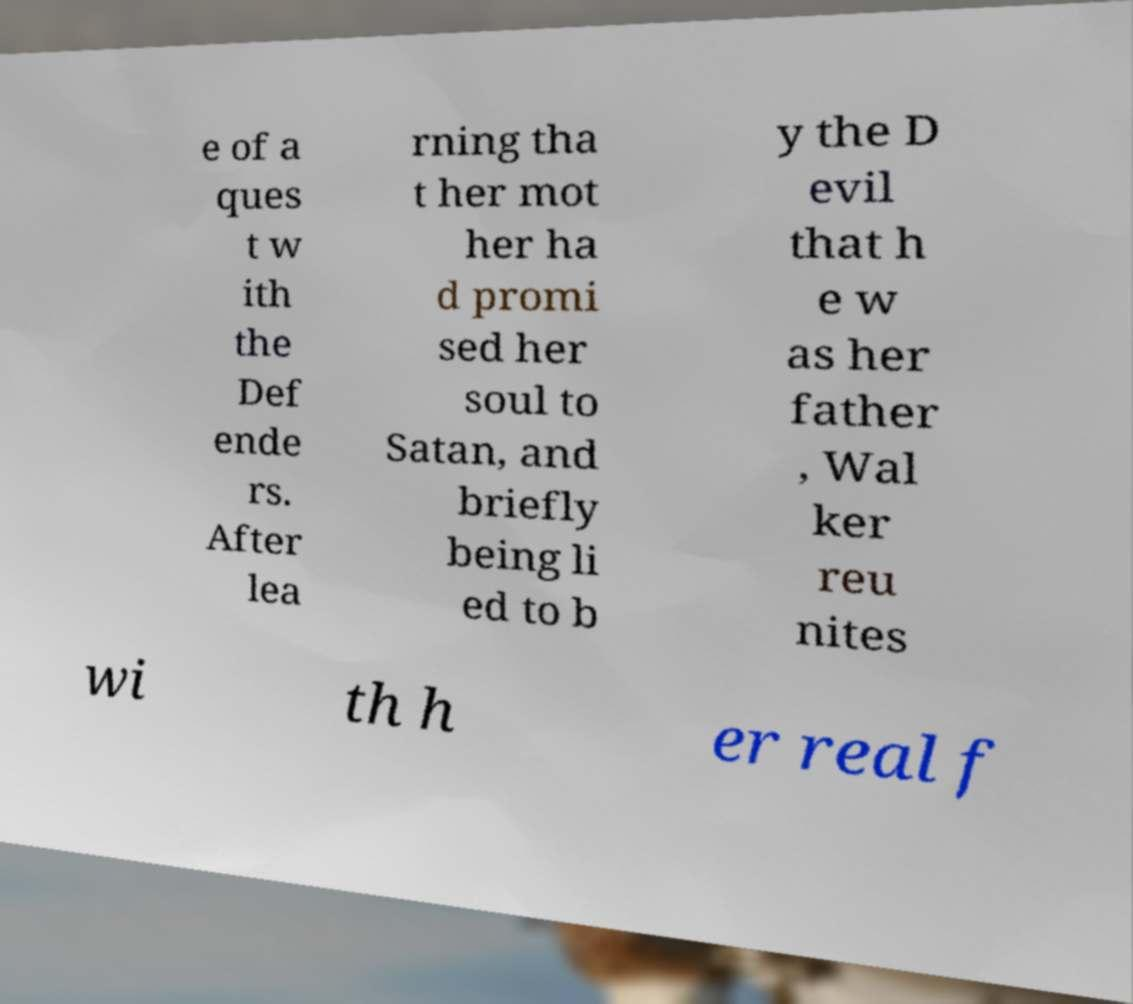Could you assist in decoding the text presented in this image and type it out clearly? e of a ques t w ith the Def ende rs. After lea rning tha t her mot her ha d promi sed her soul to Satan, and briefly being li ed to b y the D evil that h e w as her father , Wal ker reu nites wi th h er real f 